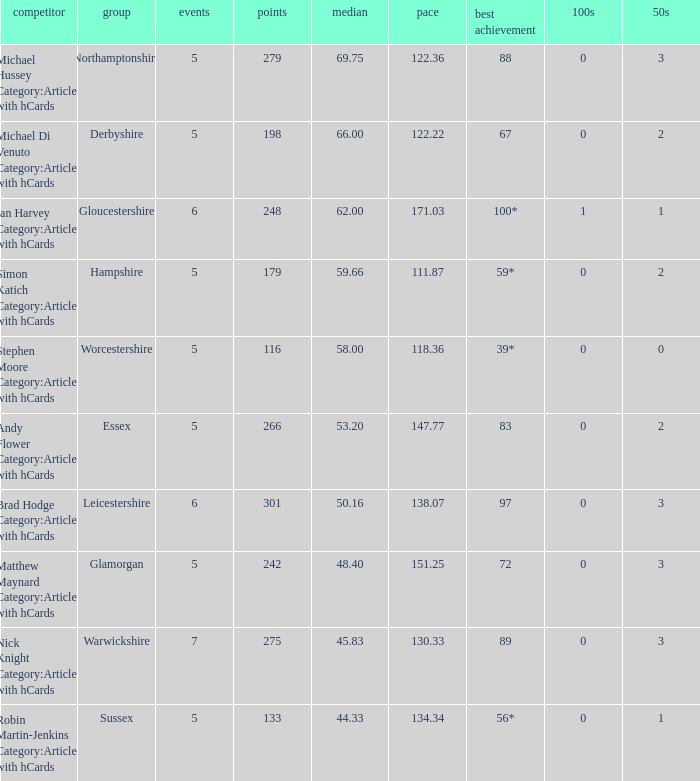If the team is Gloucestershire, what is the average? 62.0. 